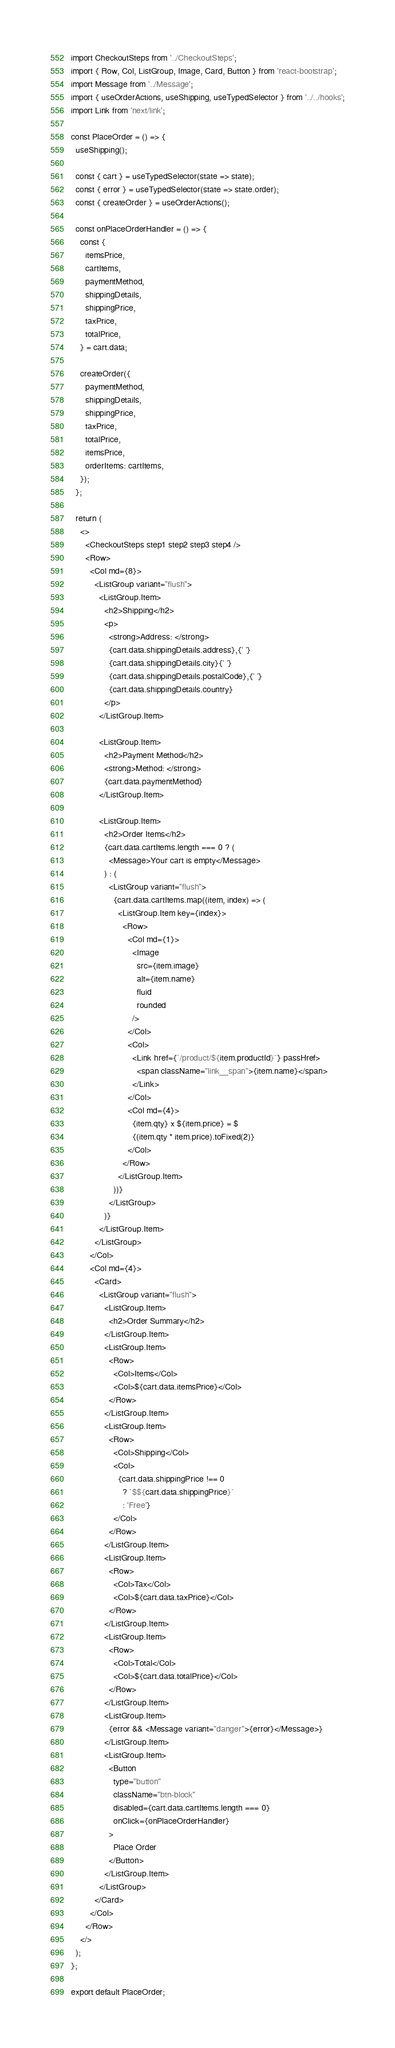<code> <loc_0><loc_0><loc_500><loc_500><_TypeScript_>import CheckoutSteps from '../CheckoutSteps';
import { Row, Col, ListGroup, Image, Card, Button } from 'react-bootstrap';
import Message from '../Message';
import { useOrderActions, useShipping, useTypedSelector } from '../../hooks';
import Link from 'next/link';

const PlaceOrder = () => {
  useShipping();

  const { cart } = useTypedSelector(state => state);
  const { error } = useTypedSelector(state => state.order);
  const { createOrder } = useOrderActions();

  const onPlaceOrderHandler = () => {
    const {
      itemsPrice,
      cartItems,
      paymentMethod,
      shippingDetails,
      shippingPrice,
      taxPrice,
      totalPrice,
    } = cart.data;

    createOrder({
      paymentMethod,
      shippingDetails,
      shippingPrice,
      taxPrice,
      totalPrice,
      itemsPrice,
      orderItems: cartItems,
    });
  };

  return (
    <>
      <CheckoutSteps step1 step2 step3 step4 />
      <Row>
        <Col md={8}>
          <ListGroup variant="flush">
            <ListGroup.Item>
              <h2>Shipping</h2>
              <p>
                <strong>Address: </strong>
                {cart.data.shippingDetails.address},{' '}
                {cart.data.shippingDetails.city}{' '}
                {cart.data.shippingDetails.postalCode},{' '}
                {cart.data.shippingDetails.country}
              </p>
            </ListGroup.Item>

            <ListGroup.Item>
              <h2>Payment Method</h2>
              <strong>Method: </strong>
              {cart.data.paymentMethod}
            </ListGroup.Item>

            <ListGroup.Item>
              <h2>Order Items</h2>
              {cart.data.cartItems.length === 0 ? (
                <Message>Your cart is empty</Message>
              ) : (
                <ListGroup variant="flush">
                  {cart.data.cartItems.map((item, index) => (
                    <ListGroup.Item key={index}>
                      <Row>
                        <Col md={1}>
                          <Image
                            src={item.image}
                            alt={item.name}
                            fluid
                            rounded
                          />
                        </Col>
                        <Col>
                          <Link href={`/product/${item.productId}`} passHref>
                            <span className="link__span">{item.name}</span>
                          </Link>
                        </Col>
                        <Col md={4}>
                          {item.qty} x ${item.price} = $
                          {(item.qty * item.price).toFixed(2)}
                        </Col>
                      </Row>
                    </ListGroup.Item>
                  ))}
                </ListGroup>
              )}
            </ListGroup.Item>
          </ListGroup>
        </Col>
        <Col md={4}>
          <Card>
            <ListGroup variant="flush">
              <ListGroup.Item>
                <h2>Order Summary</h2>
              </ListGroup.Item>
              <ListGroup.Item>
                <Row>
                  <Col>Items</Col>
                  <Col>${cart.data.itemsPrice}</Col>
                </Row>
              </ListGroup.Item>
              <ListGroup.Item>
                <Row>
                  <Col>Shipping</Col>
                  <Col>
                    {cart.data.shippingPrice !== 0
                      ? `$${cart.data.shippingPrice}`
                      : 'Free'}
                  </Col>
                </Row>
              </ListGroup.Item>
              <ListGroup.Item>
                <Row>
                  <Col>Tax</Col>
                  <Col>${cart.data.taxPrice}</Col>
                </Row>
              </ListGroup.Item>
              <ListGroup.Item>
                <Row>
                  <Col>Total</Col>
                  <Col>${cart.data.totalPrice}</Col>
                </Row>
              </ListGroup.Item>
              <ListGroup.Item>
                {error && <Message variant="danger">{error}</Message>}
              </ListGroup.Item>
              <ListGroup.Item>
                <Button
                  type="button"
                  className="btn-block"
                  disabled={cart.data.cartItems.length === 0}
                  onClick={onPlaceOrderHandler}
                >
                  Place Order
                </Button>
              </ListGroup.Item>
            </ListGroup>
          </Card>
        </Col>
      </Row>
    </>
  );
};

export default PlaceOrder;
</code> 